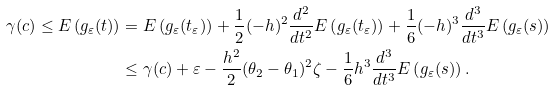<formula> <loc_0><loc_0><loc_500><loc_500>\gamma ( c ) \leq E \left ( g _ { \varepsilon } ( t ) \right ) & = E \left ( g _ { \varepsilon } ( t _ { \varepsilon } ) \right ) + \frac { 1 } { 2 } ( - h ) ^ { 2 } \frac { d ^ { 2 } } { d t ^ { 2 } } E \left ( g _ { \varepsilon } ( t _ { \varepsilon } ) \right ) + \frac { 1 } { 6 } ( - h ) ^ { 3 } \frac { d ^ { 3 } } { d t ^ { 3 } } E \left ( g _ { \varepsilon } ( s ) \right ) \\ & \leq \gamma ( c ) + \varepsilon - \frac { h ^ { 2 } } { 2 } ( \theta _ { 2 } - \theta _ { 1 } ) ^ { 2 } \zeta - \frac { 1 } { 6 } h ^ { 3 } \frac { d ^ { 3 } } { d t ^ { 3 } } E \left ( g _ { \varepsilon } ( s ) \right ) .</formula> 